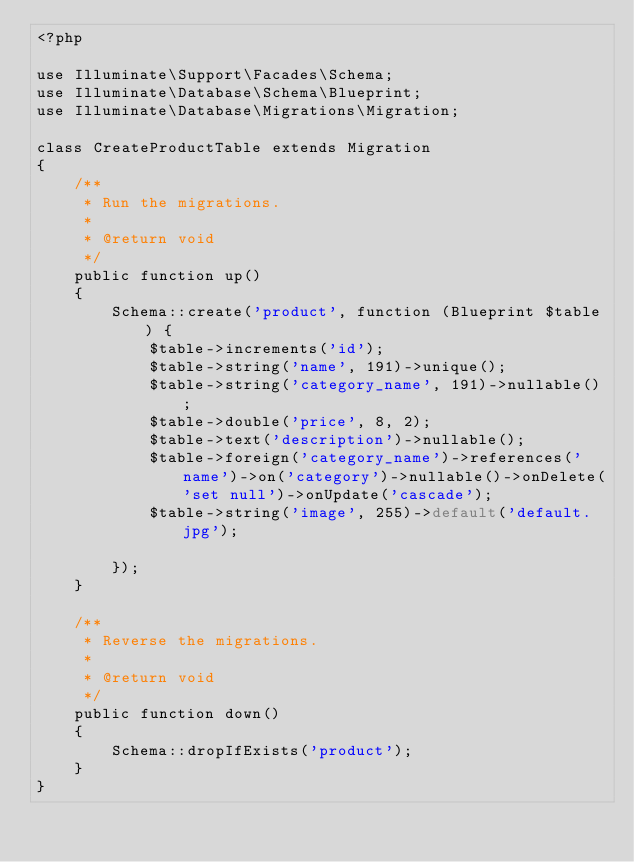Convert code to text. <code><loc_0><loc_0><loc_500><loc_500><_PHP_><?php

use Illuminate\Support\Facades\Schema;
use Illuminate\Database\Schema\Blueprint;
use Illuminate\Database\Migrations\Migration;

class CreateProductTable extends Migration
{
    /**
     * Run the migrations.
     *
     * @return void
     */
    public function up()
    {
        Schema::create('product', function (Blueprint $table) {
            $table->increments('id');
            $table->string('name', 191)->unique();
            $table->string('category_name', 191)->nullable();
            $table->double('price', 8, 2);
            $table->text('description')->nullable();
            $table->foreign('category_name')->references('name')->on('category')->nullable()->onDelete('set null')->onUpdate('cascade');
            $table->string('image', 255)->default('default.jpg');

        });
    }

    /**
     * Reverse the migrations.
     *
     * @return void
     */
    public function down()
    {
        Schema::dropIfExists('product');
    }
}
</code> 